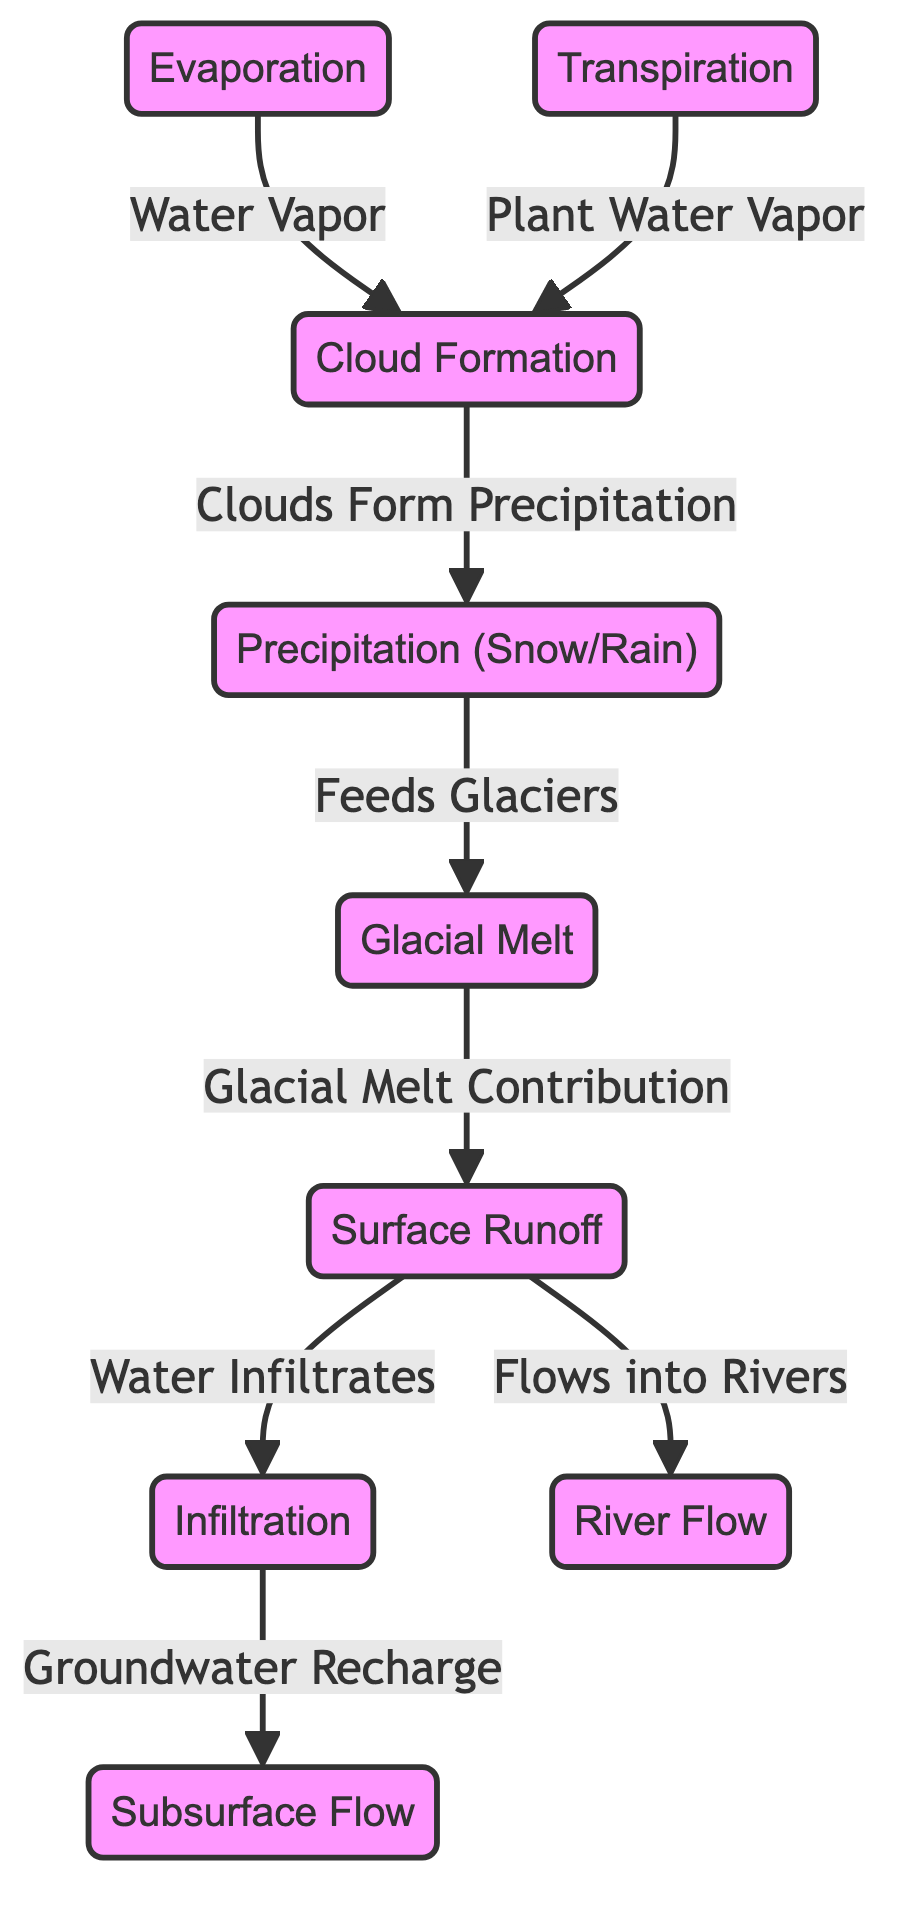What are the two sources of precipitation in this diagram? The diagram shows that precipitation comes from cloud formation, which is the result of both evaporation and transpiration. Therefore, the two sources are evaporation and transpiration.
Answer: evaporation, transpiration Which process directly contributes to surface runoff? According to the diagram, glacial melt feeds directly into surface runoff. Therefore, glacial melt is the process contributing to surface runoff.
Answer: glacial melt What flows into rivers according to the diagram? The diagram indicates that surface runoff flows into rivers. Therefore, surface runoff is the flow that contributes to river flow.
Answer: surface runoff How many nodes are present in the diagram? By counting each distinct process represented in the diagram, there are 8 nodes including evaporation, transpiration, precipitation, glacial melt, surface runoff, infiltration, subsurface flow, and river flow.
Answer: 8 What relationship exists between cloud formation and precipitation? The diagram shows a feedback loop, where cloud formation leads to precipitation. Specifically, clouds form precipitation itself, indicating a direct relationship.
Answer: Clouds Form Precipitation What is the role of infiltration in the water cycle? In the context of this diagram, infiltration serves to recharge groundwater, which is connected to subsurface flow. Thus, its role is groundwater recharge.
Answer: Groundwater Recharge How does surface runoff link to infiltration? The diagram shows that surface runoff has a direct relationship with infiltration, as surface runoff can flow into infiltration. Therefore, surface runoff links to infiltration by providing water towards groundwater recharge.
Answer: Water Infiltrates What two processes contribute to cloud formation as shown in the diagram? The diagram identifies two sources that contribute to cloud formation: evaporation (where water vapor comes from bodies of water) and transpiration (where plant water vapor is released).
Answer: evaporation, transpiration What happens to water vapor in this cycle? According to the diagram, water vapor contributes to cloud formation, which eventually leads to precipitation. This describes the cycle of water vapor returning to precipitation within the water cycle.
Answer: Cloud Formation 